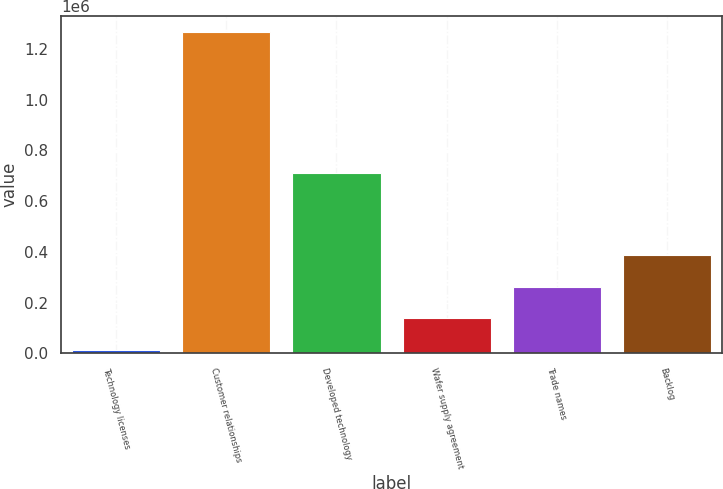Convert chart to OTSL. <chart><loc_0><loc_0><loc_500><loc_500><bar_chart><fcel>Technology licenses<fcel>Customer relationships<fcel>Developed technology<fcel>Wafer supply agreement<fcel>Trade names<fcel>Backlog<nl><fcel>12446<fcel>1.2671e+06<fcel>712163<fcel>137912<fcel>263377<fcel>388843<nl></chart> 